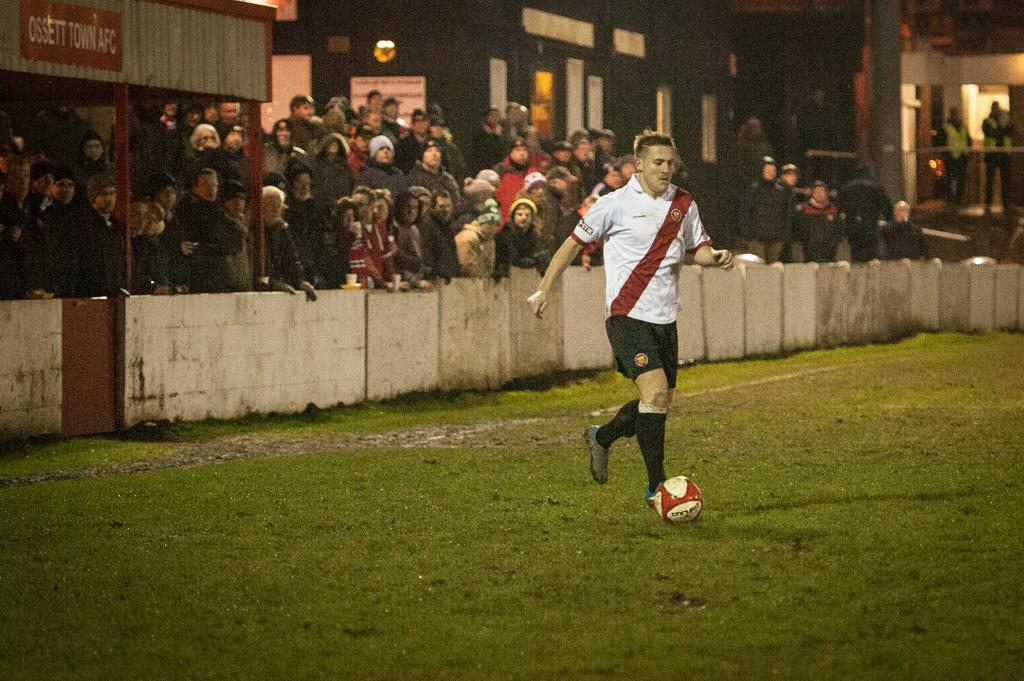What is happening in the image involving a person and a ball? A person is hitting a ball on the ground in the image. How many people are present in the image? There is a crowd of people in the image. What can be seen in the background of the image? There is a building and a fence in the background of the image. What are some features of the building in the background? The building has windows and pillars. Where is the throne located in the image? There is no throne present in the image. How many giants are visible in the image? There are no giants visible in the image. 